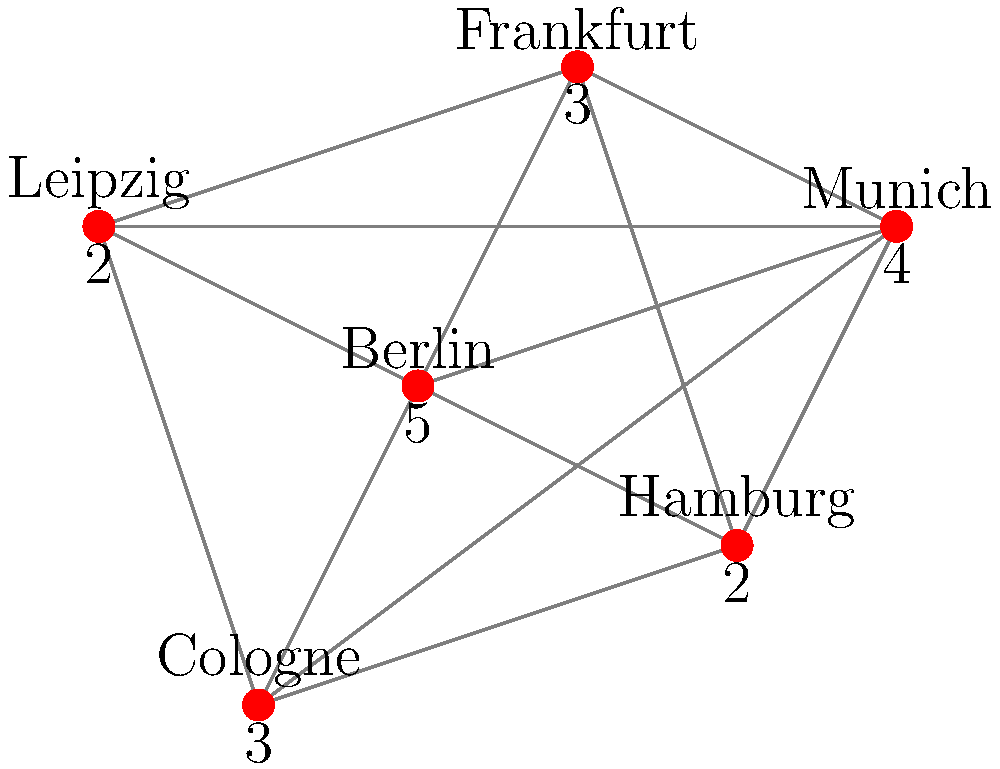In the graph representing literary events across Germany, what is the minimum number of cities that need to be visited to attend at least 10 events? To solve this problem, we need to follow these steps:

1. Identify the cities with the highest number of events:
   - Berlin: 5 events
   - Munich: 4 events
   - Frankfurt: 3 events
   - Cologne: 3 events
   - Hamburg: 2 events
   - Leipzig: 2 events

2. Start with the city having the most events (Berlin) and add its event count to our total:
   Total events = 5

3. Add the city with the next highest number of events (Munich):
   Total events = 5 + 4 = 9

4. We need at least one more event to reach 10. We can choose either Frankfurt or Cologne, both with 3 events:
   Total events = 9 + 3 = 12

Thus, by visiting Berlin, Munich, and either Frankfurt or Cologne, we can attend at least 10 events.

The minimum number of cities to visit is therefore 3.
Answer: 3 